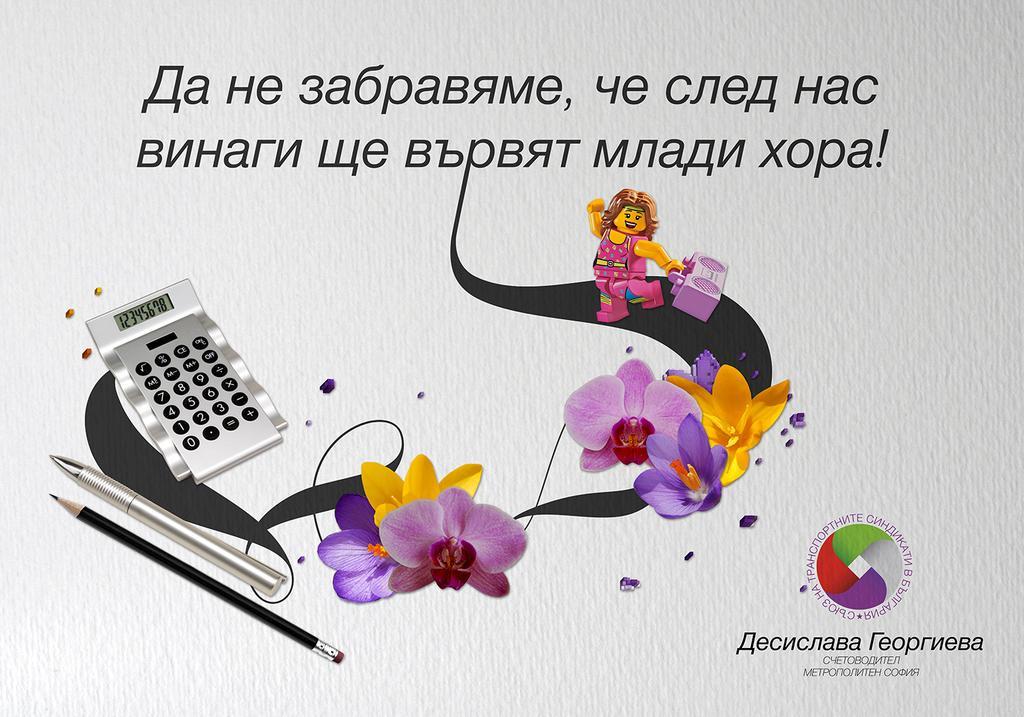Please provide a concise description of this image. It is a poster. In this image, we can see some text, logo, few objects, pen, pencil, flower and a person is holding a music player. Here we can see calculator. 